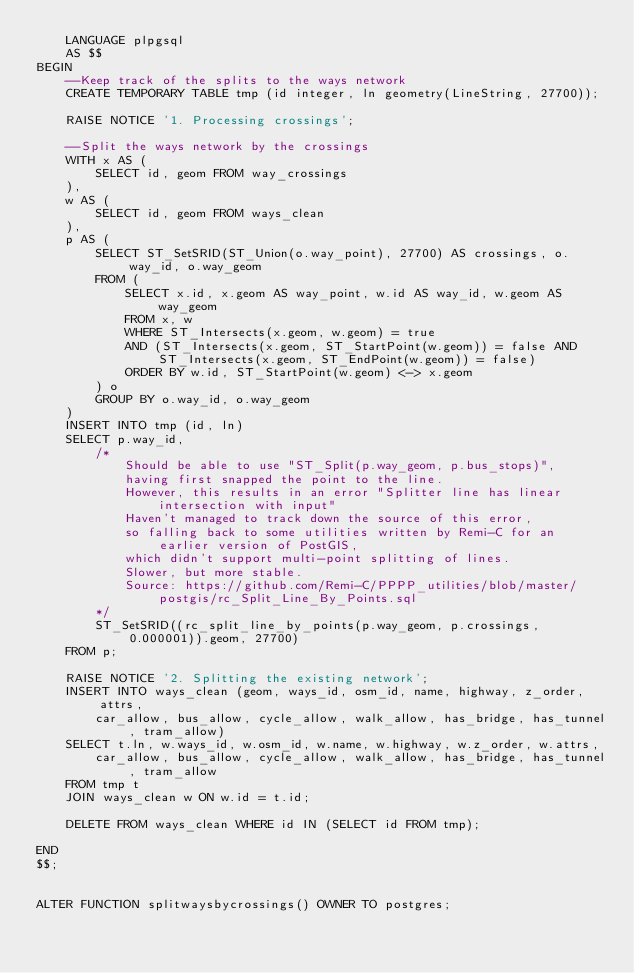Convert code to text. <code><loc_0><loc_0><loc_500><loc_500><_SQL_>    LANGUAGE plpgsql
    AS $$
BEGIN
	--Keep track of the splits to the ways network
	CREATE TEMPORARY TABLE tmp (id integer, ln geometry(LineString, 27700));
		
	RAISE NOTICE '1. Processing crossings';

	--Split the ways network by the crossings
	WITH x AS (
		SELECT id, geom FROM way_crossings
	),
	w AS (
		SELECT id, geom FROM ways_clean 
	),
	p AS (
		SELECT ST_SetSRID(ST_Union(o.way_point), 27700) AS crossings, o.way_id, o.way_geom
		FROM (			
			SELECT x.id, x.geom AS way_point, w.id AS way_id, w.geom AS way_geom 
			FROM x, w
			WHERE ST_Intersects(x.geom, w.geom) = true
			AND (ST_Intersects(x.geom, ST_StartPoint(w.geom)) = false AND ST_Intersects(x.geom, ST_EndPoint(w.geom)) = false)
			ORDER BY w.id, ST_StartPoint(w.geom) <-> x.geom
		) o
		GROUP BY o.way_id, o.way_geom
	)
	INSERT INTO tmp (id, ln)
	SELECT p.way_id, 
		/*
			Should be able to use "ST_Split(p.way_geom, p.bus_stops)",
			having first snapped the point to the line.
			However, this results in an error "Splitter line has linear intersection with input"
			Haven't managed to track down the source of this error, 
			so falling back to some utilities written by Remi-C for an earlier version of PostGIS,
			which didn't support multi-point splitting of lines. 
			Slower, but more stable.
			Source: https://github.com/Remi-C/PPPP_utilities/blob/master/postgis/rc_Split_Line_By_Points.sql
		*/
		ST_SetSRID((rc_split_line_by_points(p.way_geom, p.crossings, 0.000001)).geom, 27700)
	FROM p;	

	RAISE NOTICE '2. Splitting the existing network';
	INSERT INTO ways_clean (geom, ways_id, osm_id, name, highway, z_order, attrs,
		car_allow, bus_allow, cycle_allow, walk_allow, has_bridge, has_tunnel, tram_allow)	
	SELECT t.ln, w.ways_id, w.osm_id, w.name, w.highway, w.z_order, w.attrs,
		car_allow, bus_allow, cycle_allow, walk_allow, has_bridge, has_tunnel, tram_allow
	FROM tmp t
	JOIN ways_clean w ON w.id = t.id;
	
	DELETE FROM ways_clean WHERE id IN (SELECT id FROM tmp);
		
END 
$$;


ALTER FUNCTION splitwaysbycrossings() OWNER TO postgres;</code> 